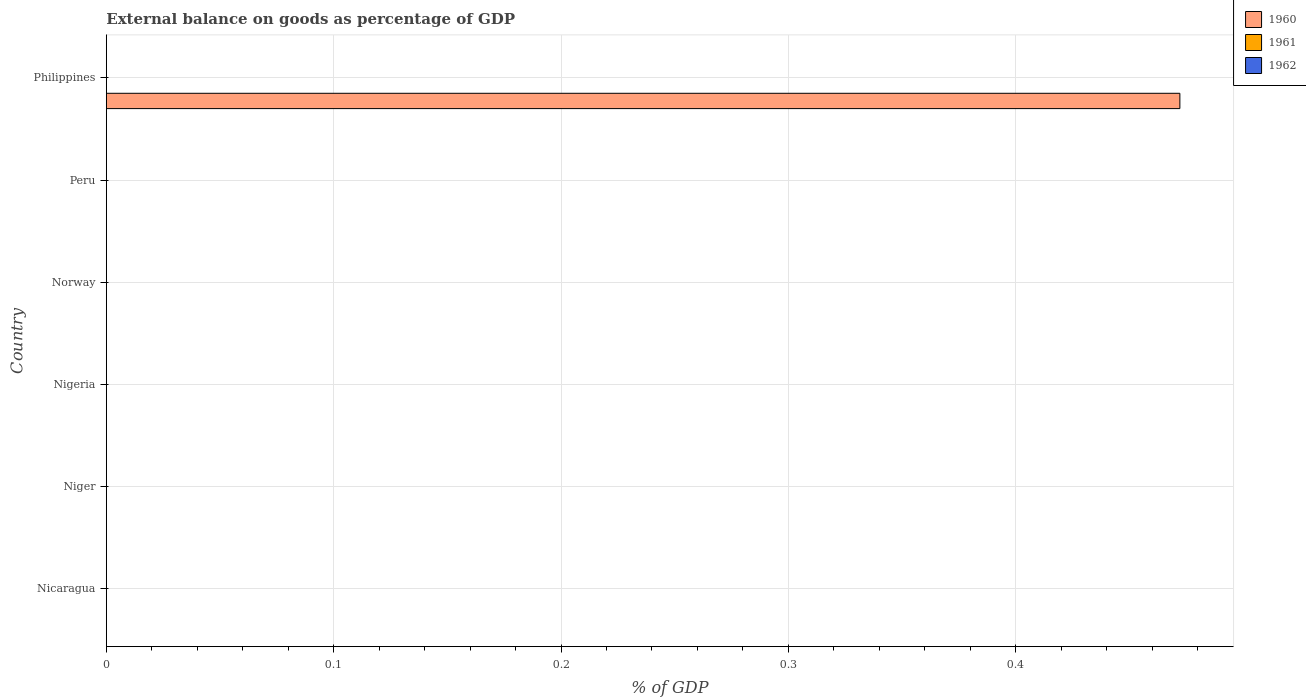Are the number of bars per tick equal to the number of legend labels?
Offer a very short reply. No. Are the number of bars on each tick of the Y-axis equal?
Make the answer very short. No. How many bars are there on the 5th tick from the bottom?
Your answer should be very brief. 0. What is the label of the 3rd group of bars from the top?
Give a very brief answer. Norway. In how many cases, is the number of bars for a given country not equal to the number of legend labels?
Keep it short and to the point. 6. What is the external balance on goods as percentage of GDP in 1960 in Philippines?
Give a very brief answer. 0.47. Across all countries, what is the maximum external balance on goods as percentage of GDP in 1960?
Offer a very short reply. 0.47. Across all countries, what is the minimum external balance on goods as percentage of GDP in 1961?
Your response must be concise. 0. In which country was the external balance on goods as percentage of GDP in 1960 maximum?
Provide a succinct answer. Philippines. What is the difference between the highest and the lowest external balance on goods as percentage of GDP in 1960?
Provide a short and direct response. 0.47. In how many countries, is the external balance on goods as percentage of GDP in 1960 greater than the average external balance on goods as percentage of GDP in 1960 taken over all countries?
Make the answer very short. 1. What is the difference between two consecutive major ticks on the X-axis?
Keep it short and to the point. 0.1. Are the values on the major ticks of X-axis written in scientific E-notation?
Give a very brief answer. No. Does the graph contain grids?
Your answer should be compact. Yes. Where does the legend appear in the graph?
Your answer should be very brief. Top right. How many legend labels are there?
Keep it short and to the point. 3. How are the legend labels stacked?
Keep it short and to the point. Vertical. What is the title of the graph?
Provide a short and direct response. External balance on goods as percentage of GDP. Does "1974" appear as one of the legend labels in the graph?
Make the answer very short. No. What is the label or title of the X-axis?
Keep it short and to the point. % of GDP. What is the % of GDP in 1961 in Nicaragua?
Provide a succinct answer. 0. What is the % of GDP of 1960 in Niger?
Offer a very short reply. 0. What is the % of GDP of 1962 in Niger?
Make the answer very short. 0. What is the % of GDP of 1961 in Nigeria?
Offer a very short reply. 0. What is the % of GDP in 1960 in Norway?
Your answer should be very brief. 0. What is the % of GDP of 1962 in Norway?
Provide a short and direct response. 0. What is the % of GDP in 1960 in Peru?
Your answer should be compact. 0. What is the % of GDP of 1962 in Peru?
Make the answer very short. 0. What is the % of GDP of 1960 in Philippines?
Give a very brief answer. 0.47. What is the % of GDP in 1961 in Philippines?
Your answer should be very brief. 0. What is the % of GDP of 1962 in Philippines?
Keep it short and to the point. 0. Across all countries, what is the maximum % of GDP of 1960?
Your answer should be compact. 0.47. What is the total % of GDP of 1960 in the graph?
Ensure brevity in your answer.  0.47. What is the total % of GDP of 1961 in the graph?
Your response must be concise. 0. What is the average % of GDP in 1960 per country?
Your response must be concise. 0.08. What is the average % of GDP in 1962 per country?
Your answer should be very brief. 0. What is the difference between the highest and the lowest % of GDP in 1960?
Your answer should be compact. 0.47. 